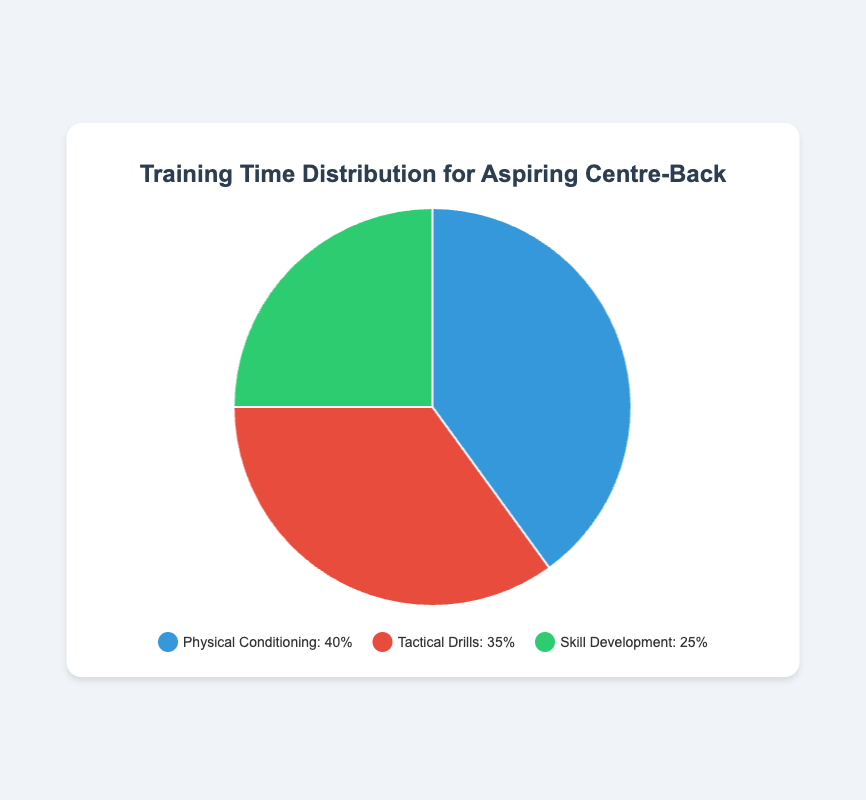Which category takes up the largest portion of training time? By looking at the percentages, "Physical Conditioning" has the highest value with 40%, which is larger than the other categories.
Answer: Physical Conditioning What is the combined training time percentage for Tactical Drills and Skill Development? Add the percentages for "Tactical Drills" (35%) and "Skill Development" (25%): 35 + 25 = 60%
Answer: 60% How much more time is spent on Physical Conditioning compared to Skill Development? Subtract the percentage for "Skill Development" (25%) from "Physical Conditioning" (40%): 40 - 25 = 15%
Answer: 15% Which training category uses the color green in the chart? By visual inspection, "Skill Development" is represented by the green color.
Answer: Skill Development What fraction of the training time is dedicated to Tactical Drills? Tactical Drills constitute 35% of the training time, which as a fraction is 35/100 or 7/20.
Answer: 7/20 If you wanted to equally distribute the training time among all three categories, by what percentage point does Skill Development need to be increased? For equal distribution among three categories, each should get 100/3 ≈ 33.33%. Currently, Skill Development is at 25%. The increase required is 33.33 - 25 ≈ 8.33 percentage points.
Answer: 8.33 Which category has the smallest percentage, and what is the difference between this and the largest percentage? "Skill Development" has the smallest percentage at 25%, and the largest is "Physical Conditioning" at 40%. The difference is 40 - 25 = 15%.
Answer: Skill Development, 15% What percentage more is dedicated to Physical Conditioning compared to Tactical Drills? Subtract the percentage for "Tactical Drills" (35%) from "Physical Conditioning" (40%): 40 - 35 = 5%. Convert the difference to a percentage of Tactical Drills: (5 / 35) * 100 ≈ 14.29%.
Answer: 14.29% If the percentage of Tactical Drills was increased by 10 percentage points, what would be the new total percentage for Physical Conditioning and Tactical Drills combined? Increase the percentage of Tactical Drills by 10 percentage points (35 + 10 = 45). Add this to the percentage for Physical Conditioning: 40 + 45 = 85%.
Answer: 85% What visual feature indicates the focus area with the least allocated training time? The smallest section of the pie chart represents the focus area with the least training time, which for this chart is the green section.
Answer: Smallest section (green) 